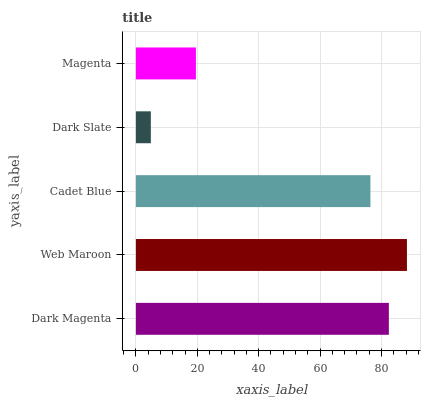Is Dark Slate the minimum?
Answer yes or no. Yes. Is Web Maroon the maximum?
Answer yes or no. Yes. Is Cadet Blue the minimum?
Answer yes or no. No. Is Cadet Blue the maximum?
Answer yes or no. No. Is Web Maroon greater than Cadet Blue?
Answer yes or no. Yes. Is Cadet Blue less than Web Maroon?
Answer yes or no. Yes. Is Cadet Blue greater than Web Maroon?
Answer yes or no. No. Is Web Maroon less than Cadet Blue?
Answer yes or no. No. Is Cadet Blue the high median?
Answer yes or no. Yes. Is Cadet Blue the low median?
Answer yes or no. Yes. Is Dark Magenta the high median?
Answer yes or no. No. Is Web Maroon the low median?
Answer yes or no. No. 